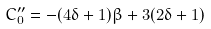<formula> <loc_0><loc_0><loc_500><loc_500>C ^ { \prime \prime } _ { 0 } = - ( 4 \delta + 1 ) \beta + 3 ( 2 \delta + 1 )</formula> 